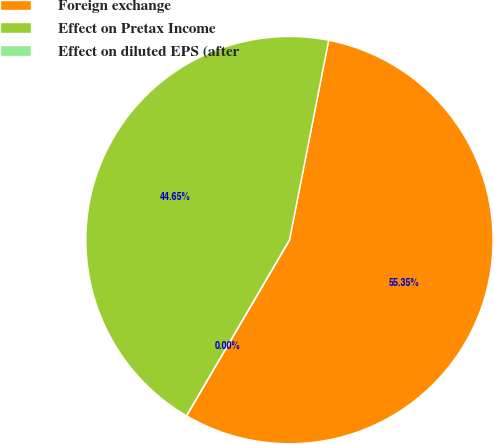<chart> <loc_0><loc_0><loc_500><loc_500><pie_chart><fcel>Foreign exchange<fcel>Effect on Pretax Income<fcel>Effect on diluted EPS (after<nl><fcel>55.35%<fcel>44.65%<fcel>0.0%<nl></chart> 